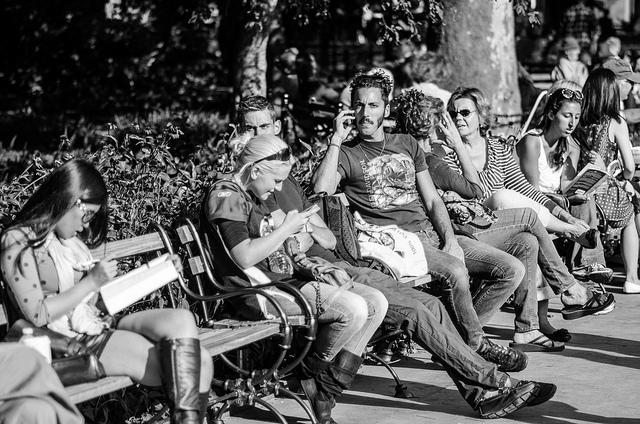What are they all doing?

Choices:
A) resting
B) relaxing
C) sleeping
D) eating relaxing 